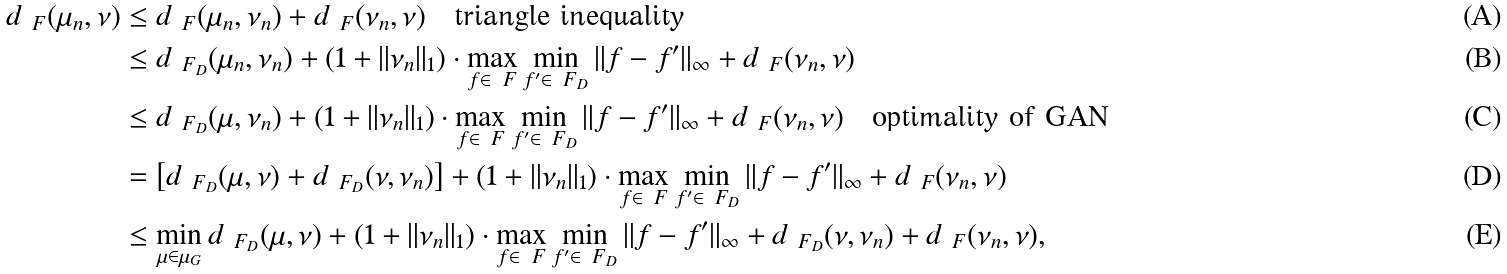<formula> <loc_0><loc_0><loc_500><loc_500>d _ { \ F } ( \mu _ { n } , \nu ) & \leq d _ { \ F } ( \mu _ { n } , \nu _ { n } ) + d _ { \ F } ( \nu _ { n } , \nu ) \quad \text {triangle inequality} \\ & \leq d _ { \ F _ { D } } ( \mu _ { n } , \nu _ { n } ) + ( 1 + \| \nu _ { n } \| _ { 1 } ) \cdot \max _ { f \in \ F } \min _ { f ^ { \prime } \in \ F _ { D } } \| f - f ^ { \prime } \| _ { \infty } + d _ { \ F } ( \nu _ { n } , \nu ) \\ & \leq d _ { \ F _ { D } } ( \mu , \nu _ { n } ) + ( 1 + \| \nu _ { n } \| _ { 1 } ) \cdot \max _ { f \in \ F } \min _ { f ^ { \prime } \in \ F _ { D } } \| f - f ^ { \prime } \| _ { \infty } + d _ { \ F } ( \nu _ { n } , \nu ) \quad \text {optimality of GAN} \\ & = \left [ d _ { \ F _ { D } } ( \mu , \nu ) + d _ { \ F _ { D } } ( \nu , \nu _ { n } ) \right ] + ( 1 + \| \nu _ { n } \| _ { 1 } ) \cdot \max _ { f \in \ F } \min _ { f ^ { \prime } \in \ F _ { D } } \| f - f ^ { \prime } \| _ { \infty } + d _ { \ F } ( \nu _ { n } , \nu ) \\ & \leq \min _ { \mu \in \mu _ { G } } d _ { \ F _ { D } } ( \mu , \nu ) + ( 1 + \| \nu _ { n } \| _ { 1 } ) \cdot \max _ { f \in \ F } \min _ { f ^ { \prime } \in \ F _ { D } } \| f - f ^ { \prime } \| _ { \infty } + d _ { \ F _ { D } } ( \nu , \nu _ { n } ) + d _ { \ F } ( \nu _ { n } , \nu ) ,</formula> 